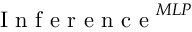Convert formula to latex. <formula><loc_0><loc_0><loc_500><loc_500>I n f e r e n c e ^ { M L P }</formula> 